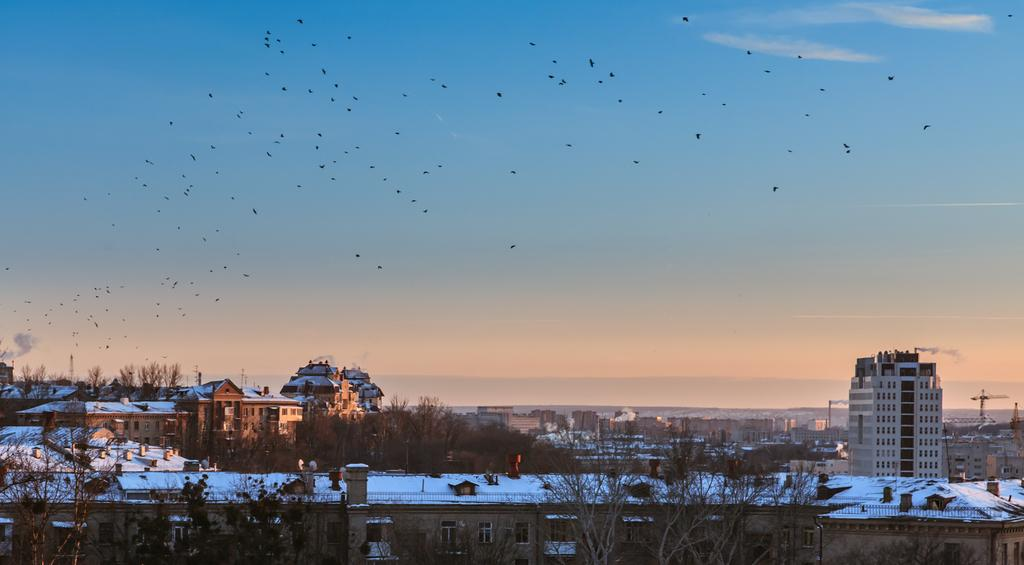What is happening in the sky in the image? There are birds flying in the air in the image. What is the condition of the buildings in the image? The buildings in the image are covered with snow. What type of vegetation can be seen between the buildings in the image? Trees are present between the buildings in the image. How much pain are the birds experiencing while flying in the image? There is no indication of pain experienced by the birds in the image. How many sheep can be seen grazing in the image? There are no sheep present in the image. 